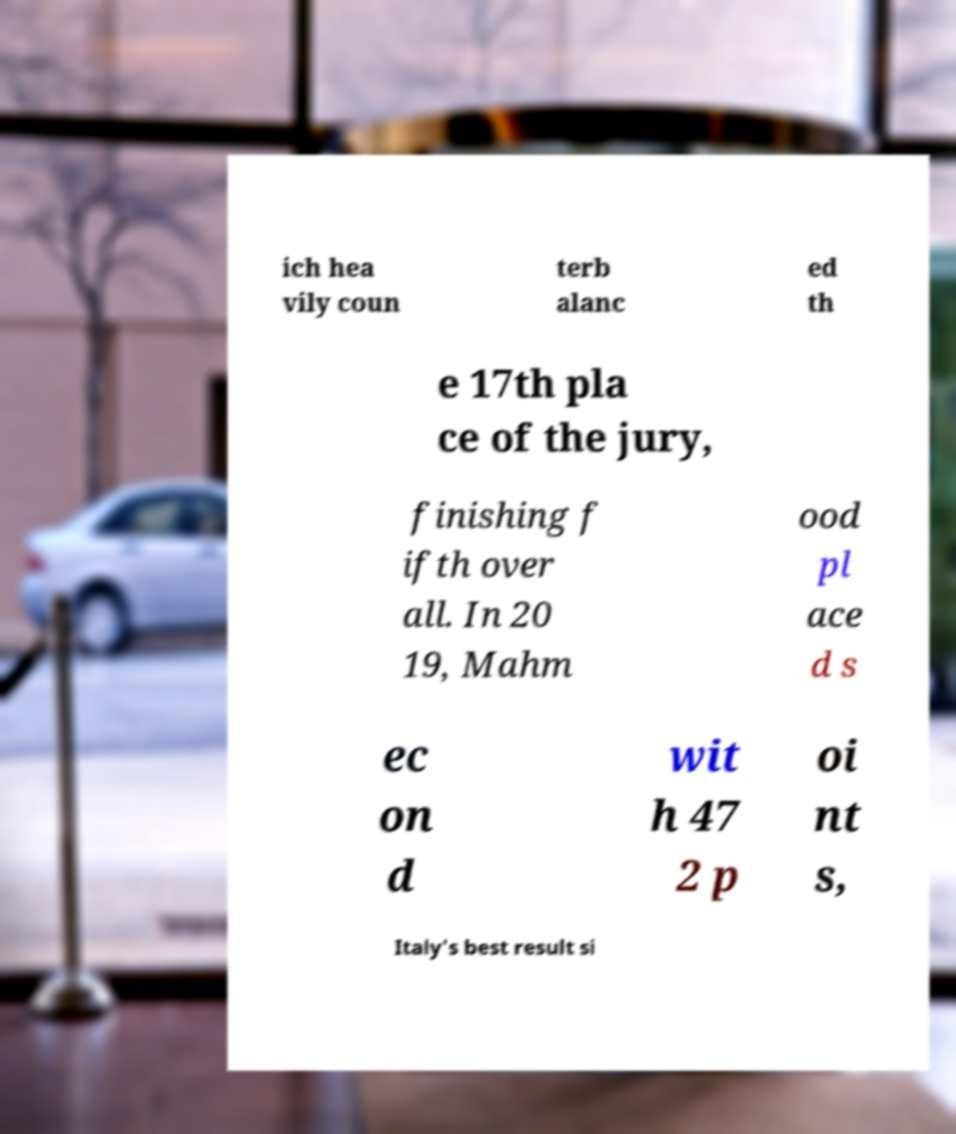Can you read and provide the text displayed in the image?This photo seems to have some interesting text. Can you extract and type it out for me? ich hea vily coun terb alanc ed th e 17th pla ce of the jury, finishing f ifth over all. In 20 19, Mahm ood pl ace d s ec on d wit h 47 2 p oi nt s, Italy's best result si 